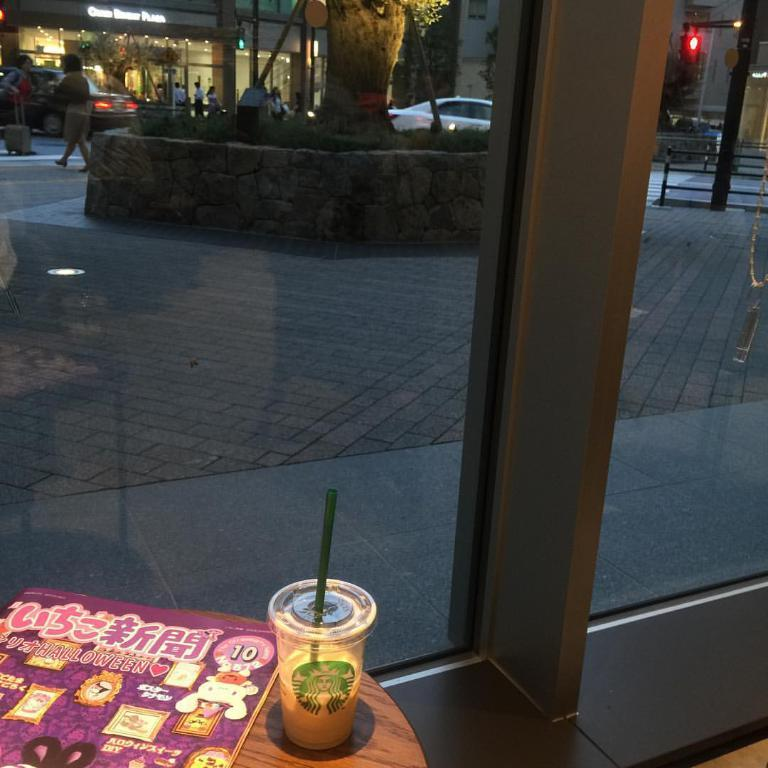What is on the table in the image? There is a glass, a straw, and a book on the table. What can be seen in the background of the image? There are group of people walking in the street, buildings, a tree, a car, a garden, signal lights, and iron rods in the background. What is the temperature in the image? The image does not provide information about the temperature, so it cannot be determined. What month is it in the image? The image does not provide information about the month, so it cannot be determined. 